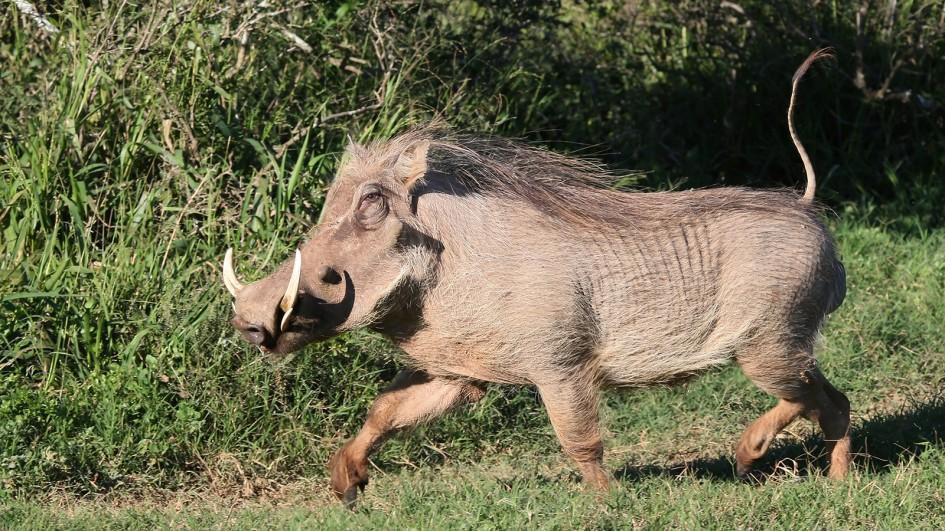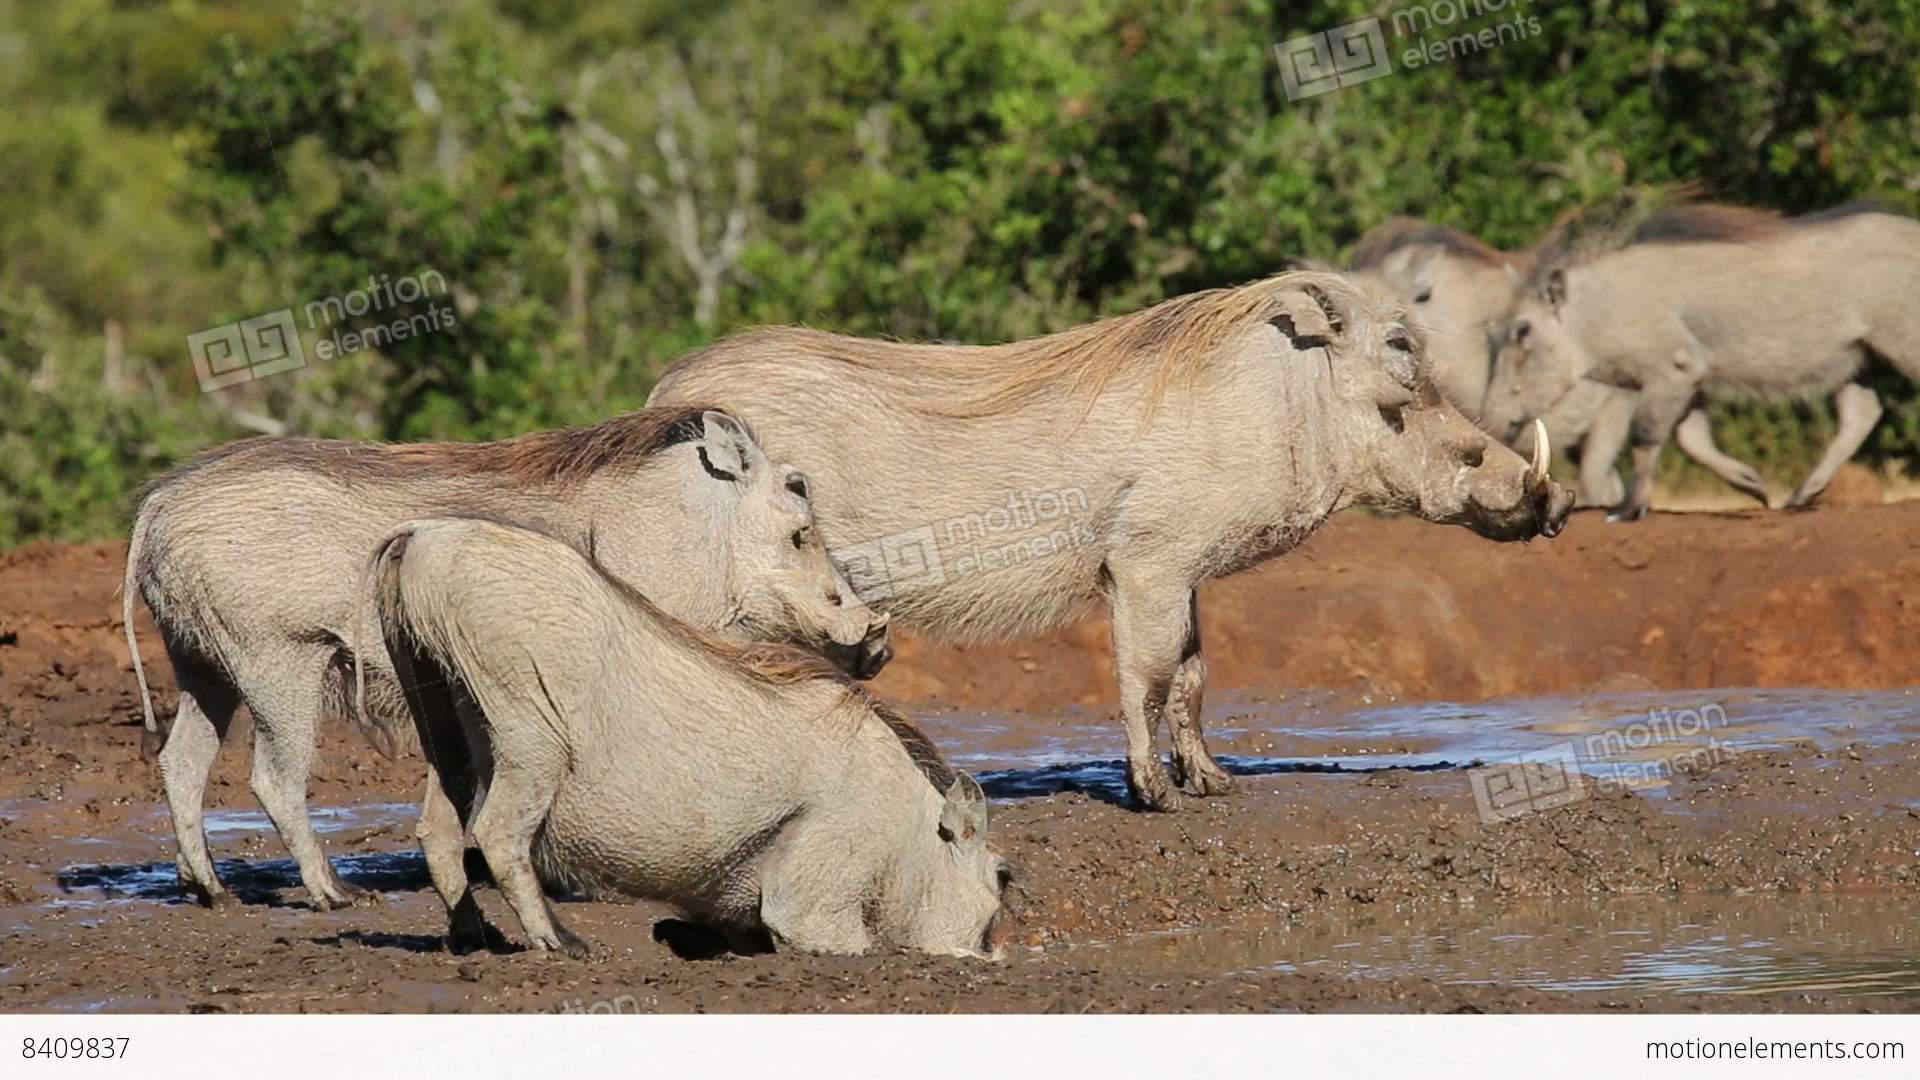The first image is the image on the left, the second image is the image on the right. For the images shown, is this caption "there is only one adult animal in the image on the left" true? Answer yes or no. Yes. The first image is the image on the left, the second image is the image on the right. Considering the images on both sides, is "There is at least one hog facing left." valid? Answer yes or no. Yes. 